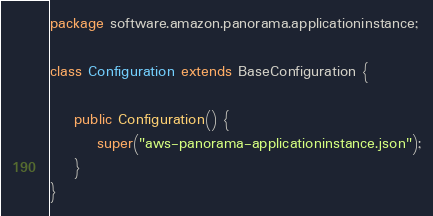Convert code to text. <code><loc_0><loc_0><loc_500><loc_500><_Java_>package software.amazon.panorama.applicationinstance;

class Configuration extends BaseConfiguration {

    public Configuration() {
        super("aws-panorama-applicationinstance.json");
    }
}
</code> 